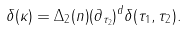<formula> <loc_0><loc_0><loc_500><loc_500>\delta ( \kappa ) = \Delta _ { 2 } ( n ) ( \partial _ { \tau _ { 2 } } ) ^ { d } \delta ( \tau _ { 1 } , \tau _ { 2 } ) .</formula> 